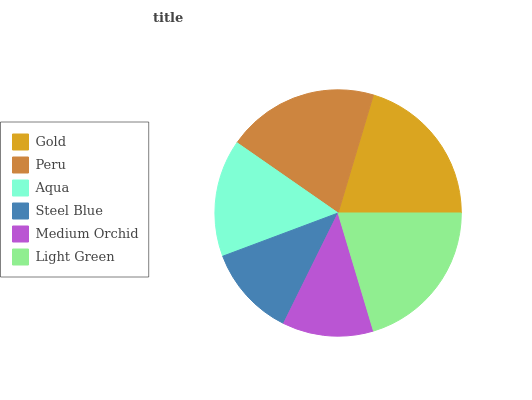Is Medium Orchid the minimum?
Answer yes or no. Yes. Is Gold the maximum?
Answer yes or no. Yes. Is Peru the minimum?
Answer yes or no. No. Is Peru the maximum?
Answer yes or no. No. Is Gold greater than Peru?
Answer yes or no. Yes. Is Peru less than Gold?
Answer yes or no. Yes. Is Peru greater than Gold?
Answer yes or no. No. Is Gold less than Peru?
Answer yes or no. No. Is Peru the high median?
Answer yes or no. Yes. Is Aqua the low median?
Answer yes or no. Yes. Is Gold the high median?
Answer yes or no. No. Is Light Green the low median?
Answer yes or no. No. 